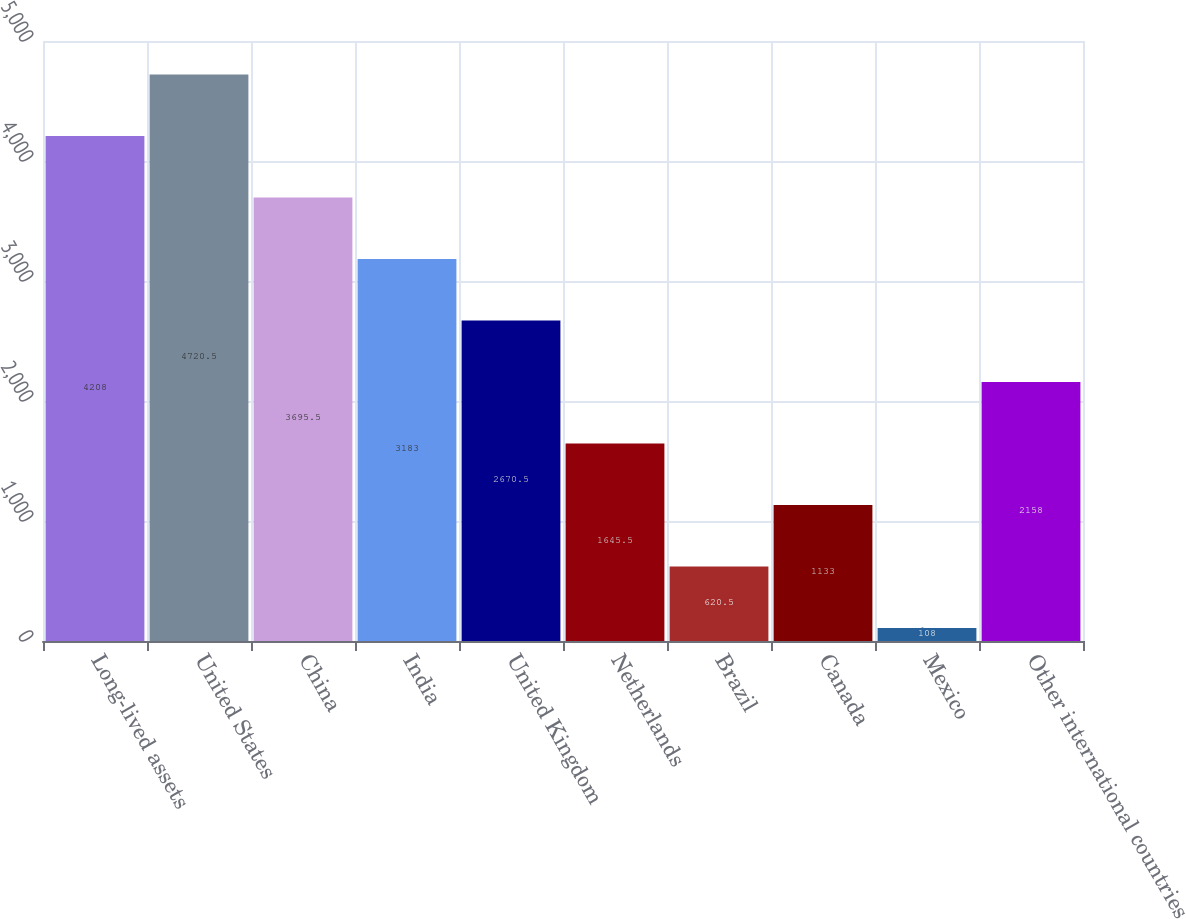Convert chart. <chart><loc_0><loc_0><loc_500><loc_500><bar_chart><fcel>Long-lived assets<fcel>United States<fcel>China<fcel>India<fcel>United Kingdom<fcel>Netherlands<fcel>Brazil<fcel>Canada<fcel>Mexico<fcel>Other international countries<nl><fcel>4208<fcel>4720.5<fcel>3695.5<fcel>3183<fcel>2670.5<fcel>1645.5<fcel>620.5<fcel>1133<fcel>108<fcel>2158<nl></chart> 